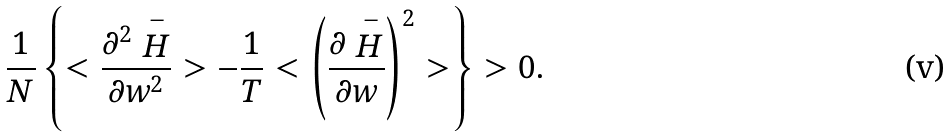<formula> <loc_0><loc_0><loc_500><loc_500>\frac { 1 } { N } \left \{ < \frac { \partial ^ { 2 } \stackrel { - } { H } } { \partial w ^ { 2 } } > - \frac { 1 } { T } < \left ( \frac { \partial \stackrel { - } { H } } { \partial w } \right ) ^ { 2 } > \right \} > 0 .</formula> 